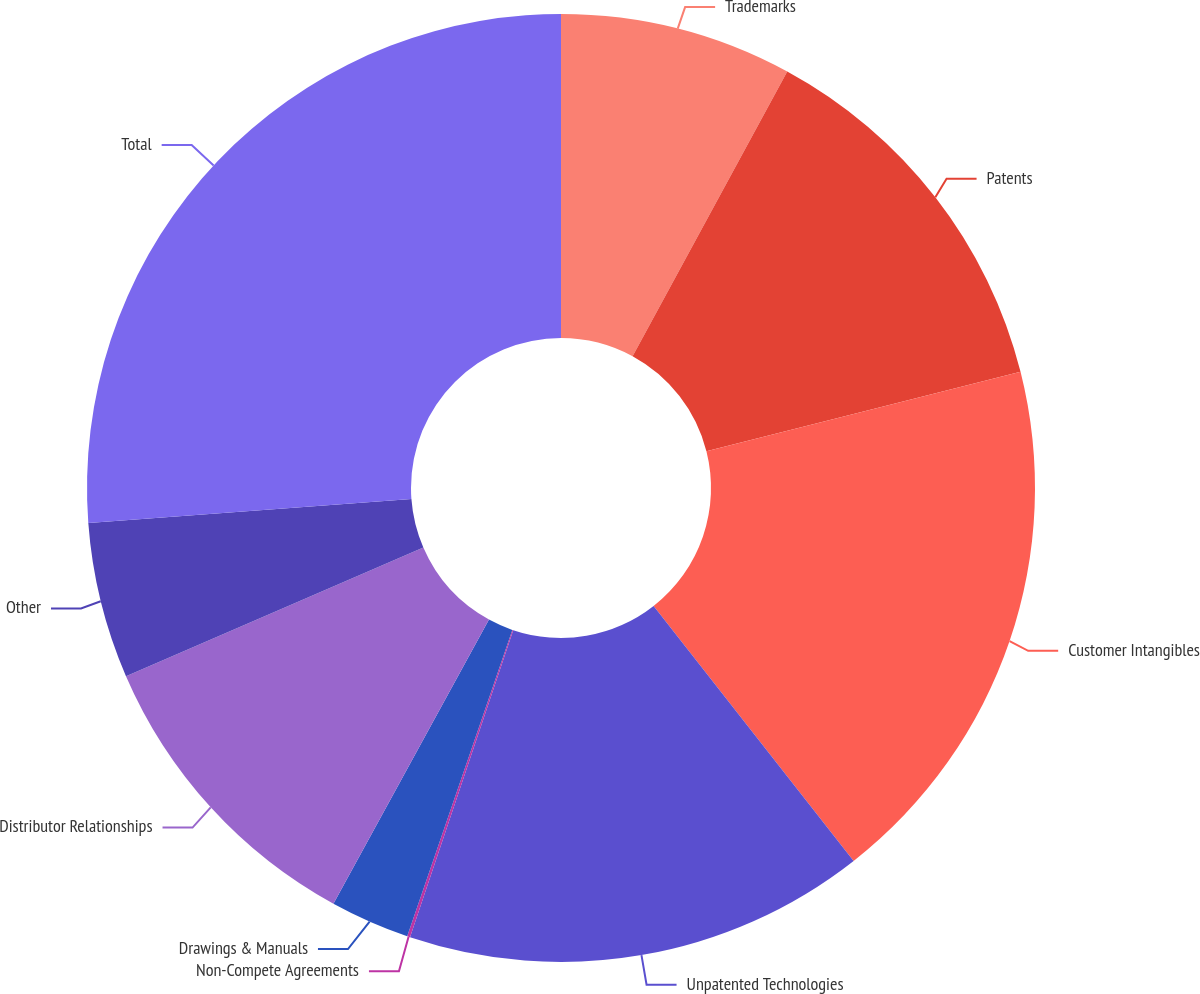Convert chart. <chart><loc_0><loc_0><loc_500><loc_500><pie_chart><fcel>Trademarks<fcel>Patents<fcel>Customer Intangibles<fcel>Unpatented Technologies<fcel>Non-Compete Agreements<fcel>Drawings & Manuals<fcel>Distributor Relationships<fcel>Other<fcel>Total<nl><fcel>7.92%<fcel>13.14%<fcel>18.35%<fcel>15.75%<fcel>0.1%<fcel>2.71%<fcel>10.53%<fcel>5.32%<fcel>26.18%<nl></chart> 